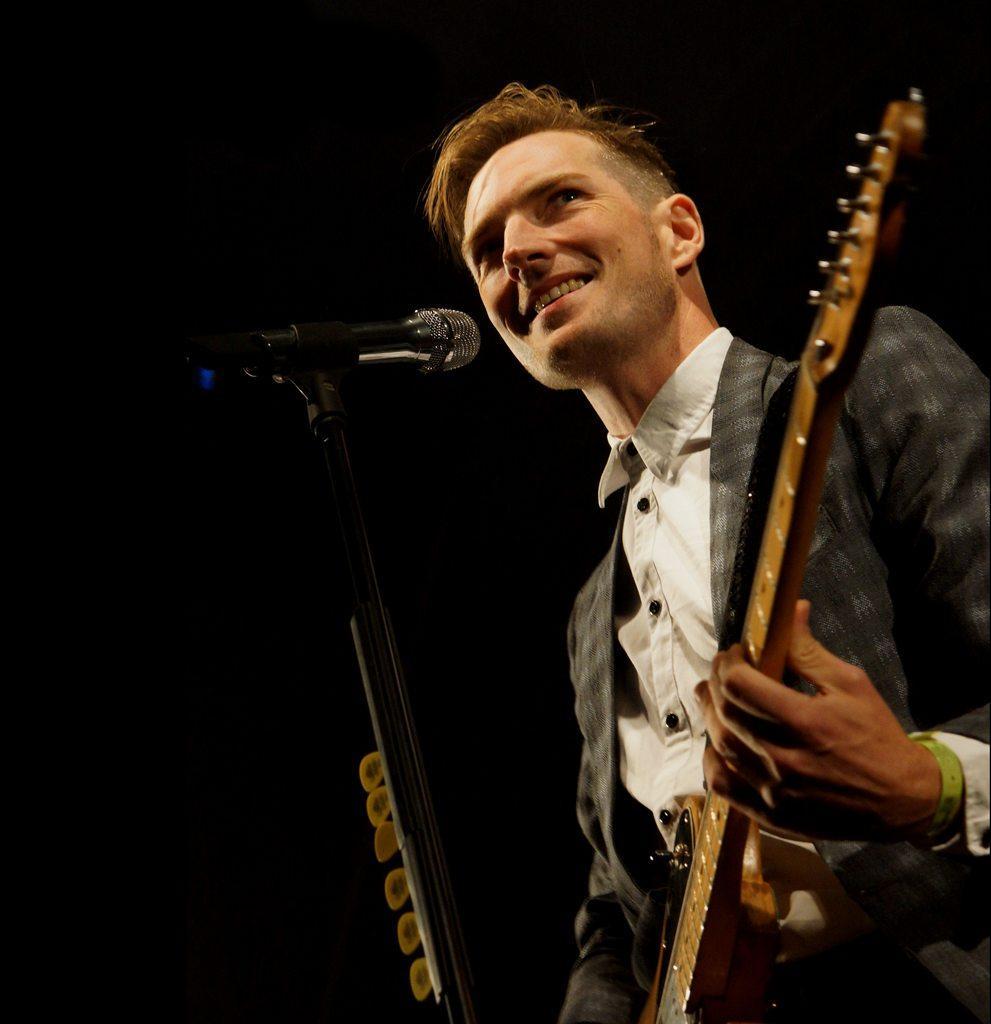Describe this image in one or two sentences. In this picture one person is standing and he is holding a guitar in front of the person there is a microphone and he is just singing a song and playing a guitar. 